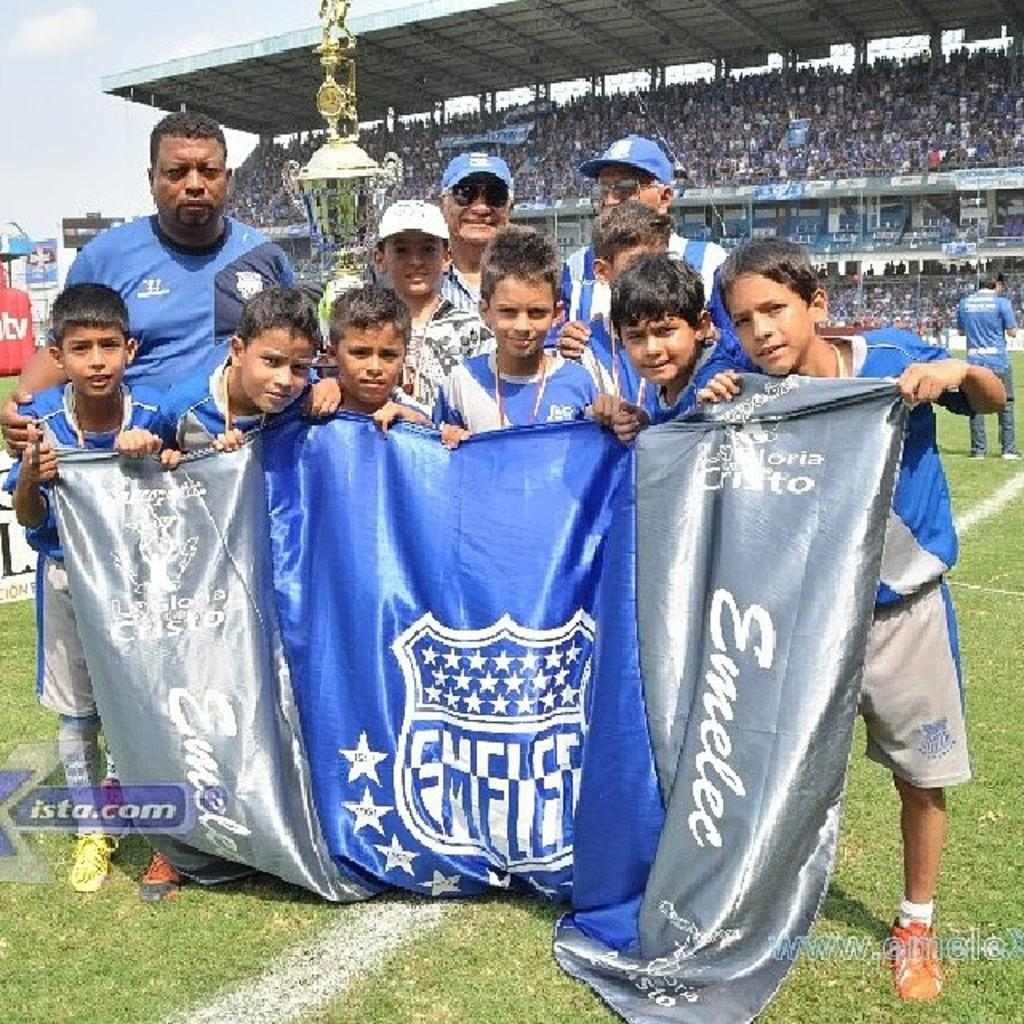<image>
Relay a brief, clear account of the picture shown. A group of boys that holding a flag that says Emelee 